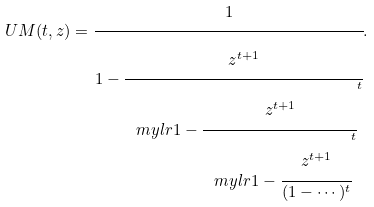<formula> <loc_0><loc_0><loc_500><loc_500>U M ( t , z ) = \cfrac { 1 } { 1 - \cfrac { z ^ { t + 1 } } { \ m y l r { 1 - \cfrac { z ^ { t + 1 } } { \ m y l r { 1 - \cfrac { z ^ { t + 1 } } { ( 1 - \cdots ) ^ { t } } } ^ { t } } } ^ { t } } } .</formula> 